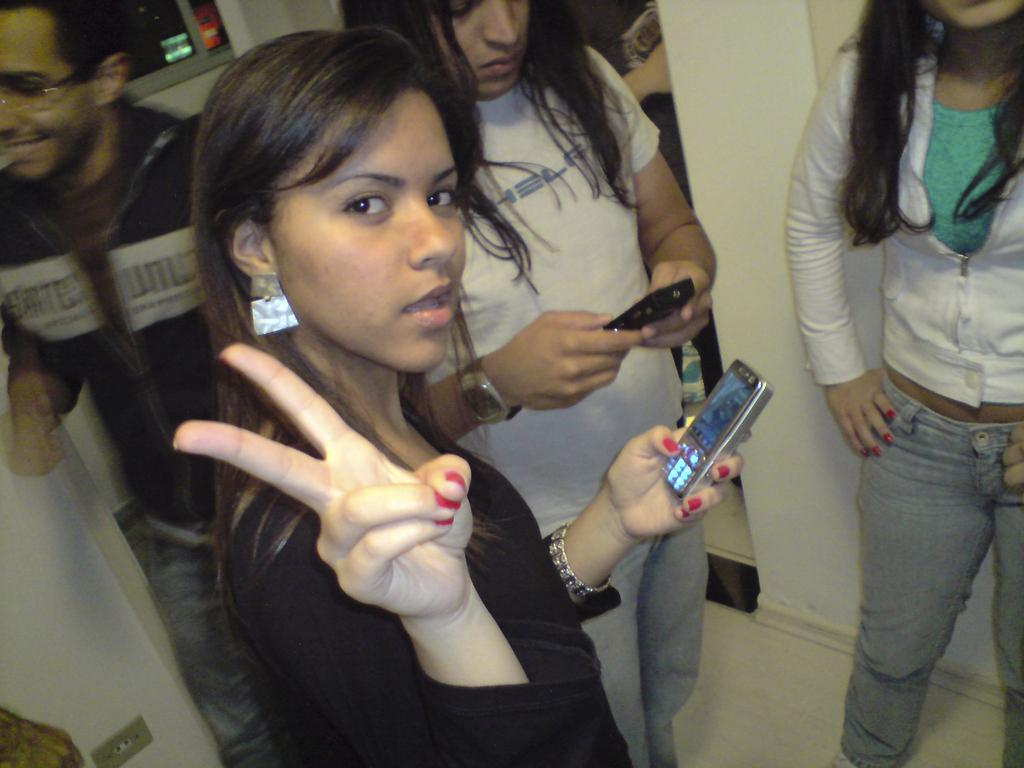How many people are present in the image? There are four persons standing on the floor. What are the people holding in their hands? Each person is holding a mobile in their hands. Can you describe the facial expression of one of the persons? A woman is smiling among the group. What can be seen in the background of the image? There is a window and a pillar in the background. What type of payment is being made by the persons in the image? There is no indication of any payment being made in the image; the people are simply holding mobiles. What attraction is visible through the window in the background? There is no attraction visible through the window in the image; only the window and the pillar are mentioned. 